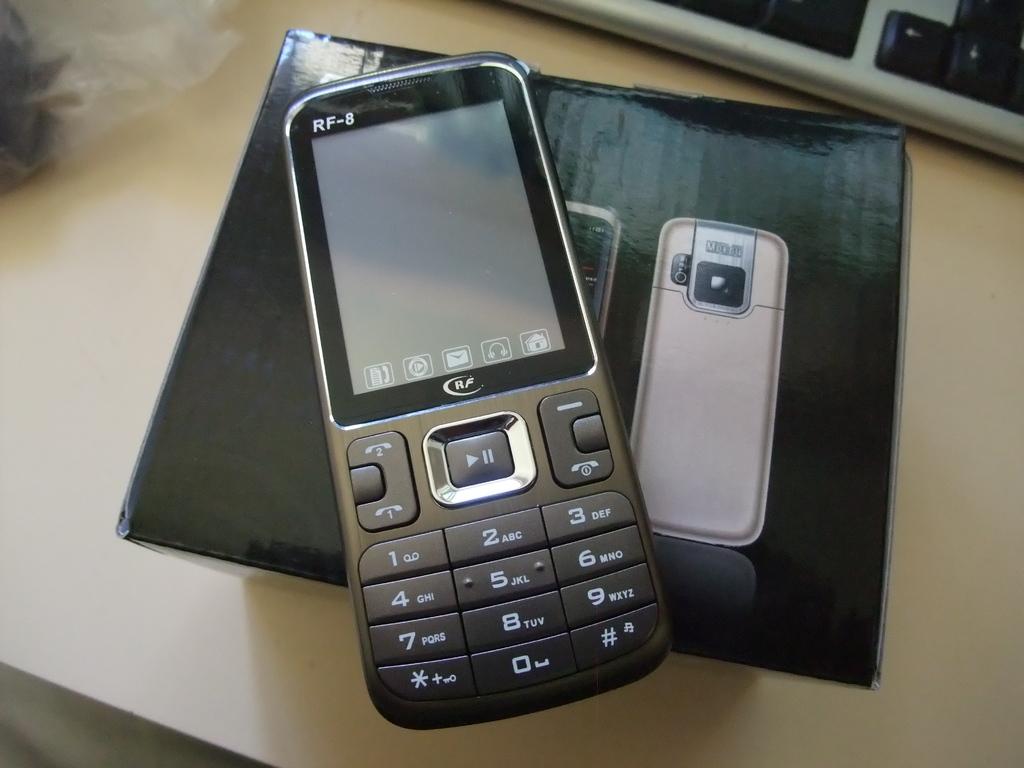What model is this phone?
Your answer should be compact. Rf-8. If i wanted to start typing a name that started with c which numeric key would i press?
Offer a very short reply. 2. 